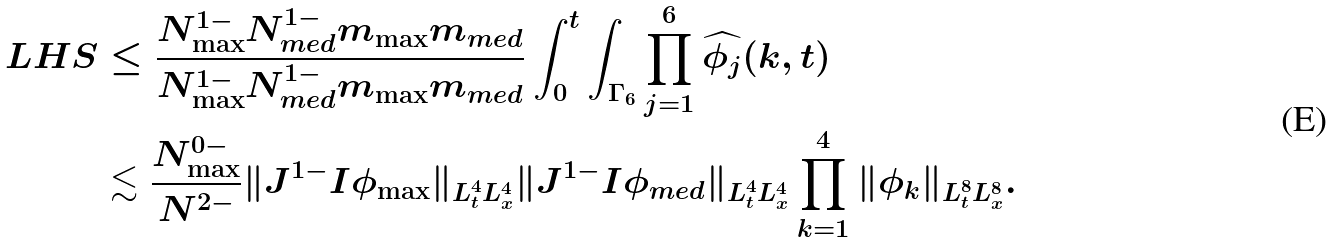<formula> <loc_0><loc_0><loc_500><loc_500>L H S & \leq \frac { N _ { \max } ^ { 1 - } N _ { m e d } ^ { 1 - } m _ { \max } m _ { m e d } } { N _ { \max } ^ { 1 - } N _ { m e d } ^ { 1 - } m _ { \max } m _ { m e d } } \int _ { 0 } ^ { t } \int _ { \Gamma _ { 6 } } \prod _ { j = 1 } ^ { 6 } \widehat { \phi _ { j } } ( k , t ) \\ & \lesssim \frac { N _ { \max } ^ { 0 - } } { N ^ { 2 - } } \| J ^ { 1 - } I \phi _ { \max } \| _ { L ^ { 4 } _ { t } L ^ { 4 } _ { x } } \| J ^ { 1 - } I \phi _ { m e d } \| _ { L ^ { 4 } _ { t } L ^ { 4 } _ { x } } \prod _ { k = 1 } ^ { 4 } \| \phi _ { k } \| _ { L ^ { 8 } _ { t } L ^ { 8 } _ { x } } .</formula> 